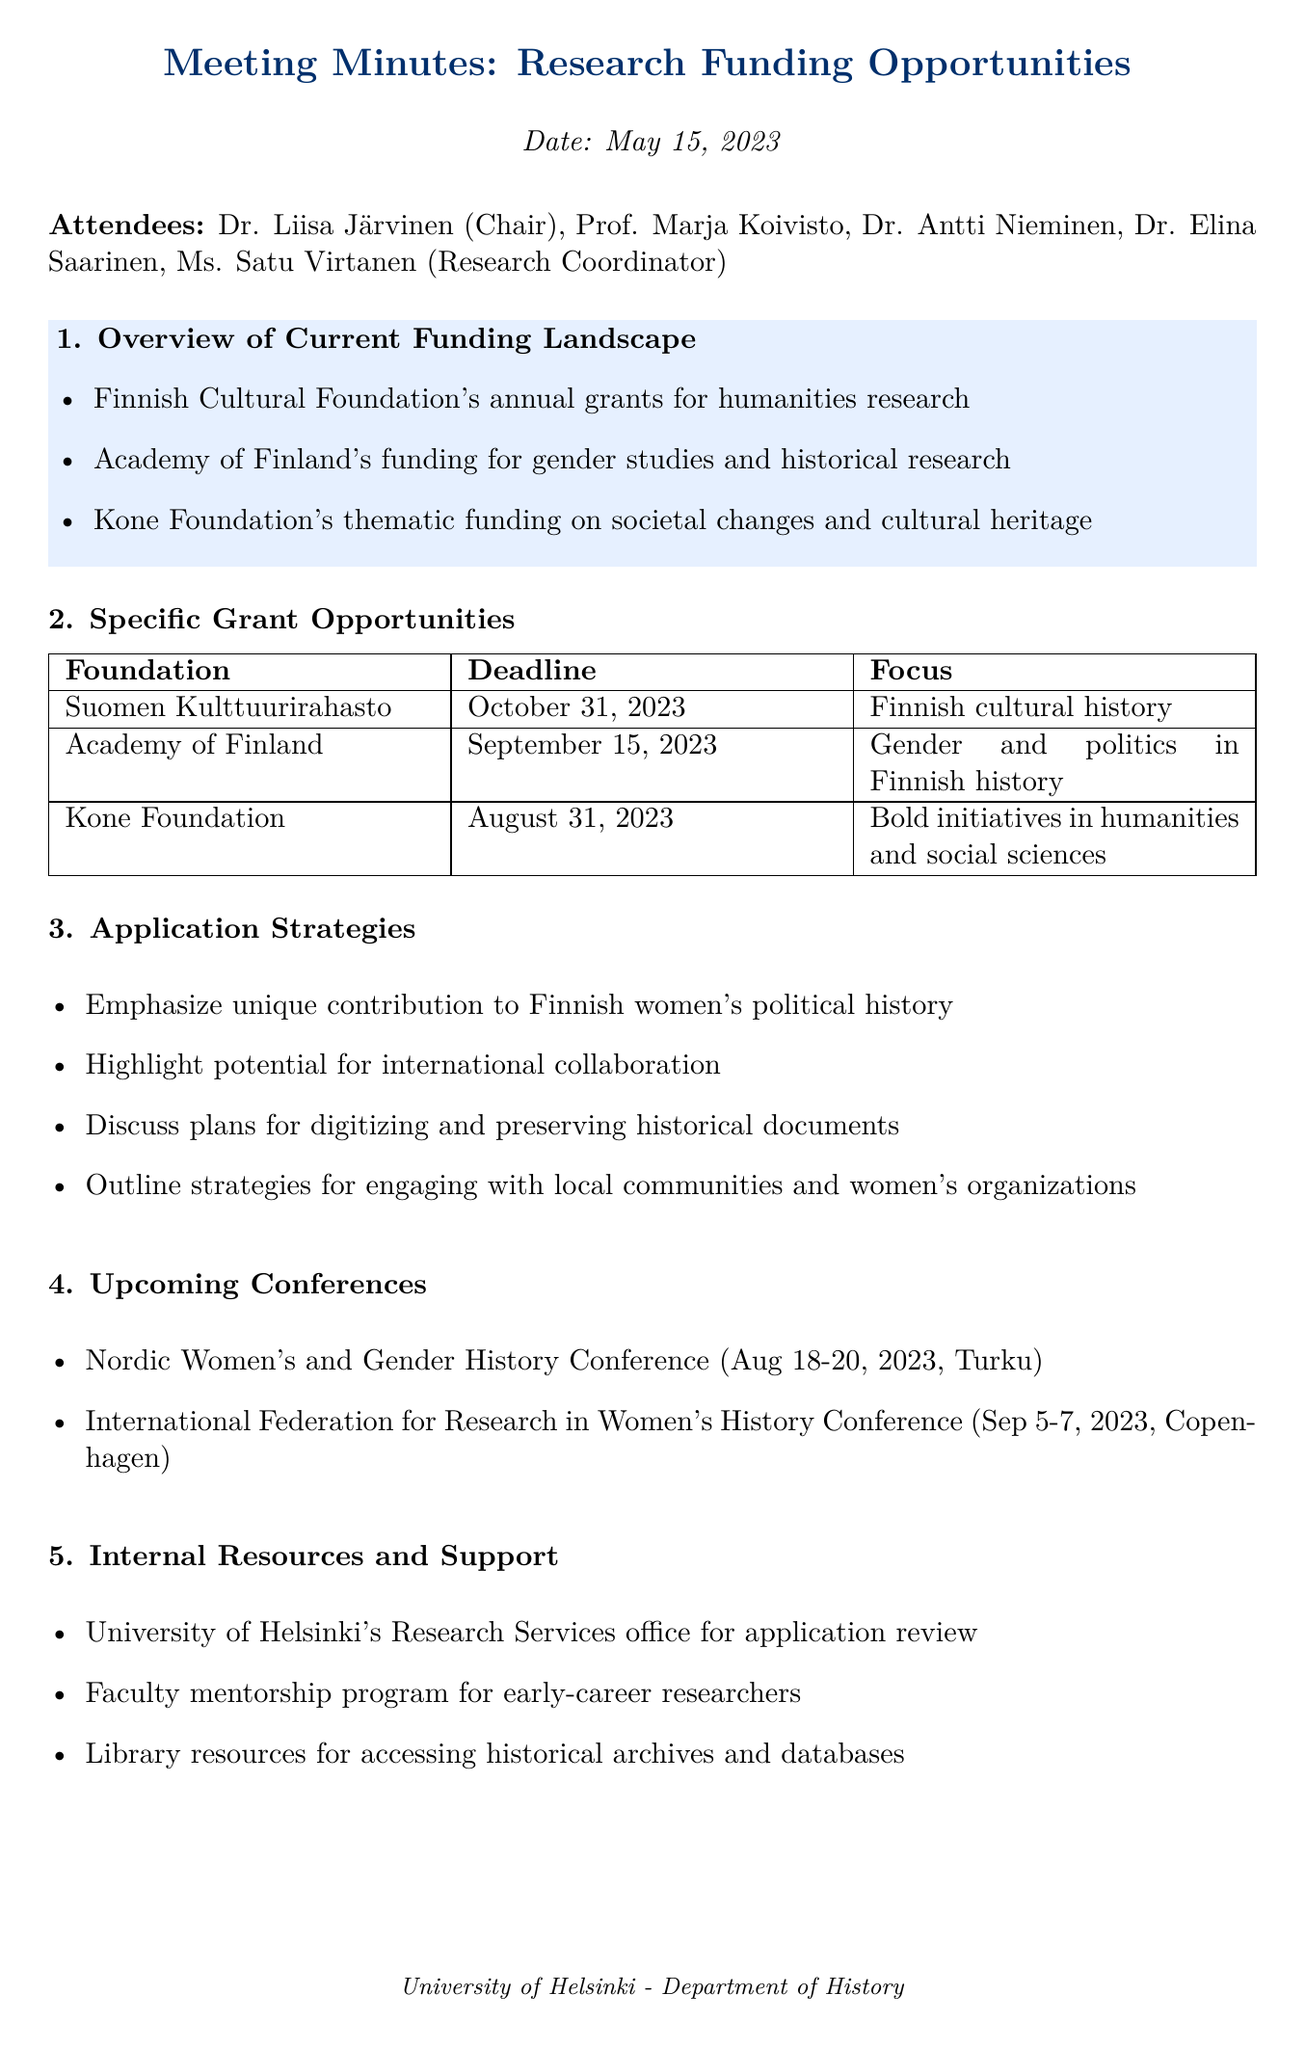What is the meeting date? The meeting date is mentioned at the beginning of the document.
Answer: May 15, 2023 Who is the Chair of the meeting? The document lists Dr. Liisa Järvinen as the Chair among the attendees.
Answer: Dr. Liisa Järvinen What is the deadline for the Kone Foundation grant? The document provides specific deadlines for each grant opportunity.
Answer: August 31, 2023 What is the focus of the Academy of Finland grant? The focus for each grant is outlined in the specific grant opportunities section.
Answer: Gender and politics in Finnish history Which conference occurs on August 18-20, 2023? The upcoming conferences section lists the events with their respective dates.
Answer: Nordic Women's and Gender History Conference What application strategy emphasizes engaging with local communities? The strategies for application highlight various approaches including community engagement.
Answer: Outline strategies for engaging with local communities and women's organizations Who is responsible for organizing a grant writing workshop? The action items section assigns this task to Ms. Virtanen.
Answer: Ms. Virtanen 